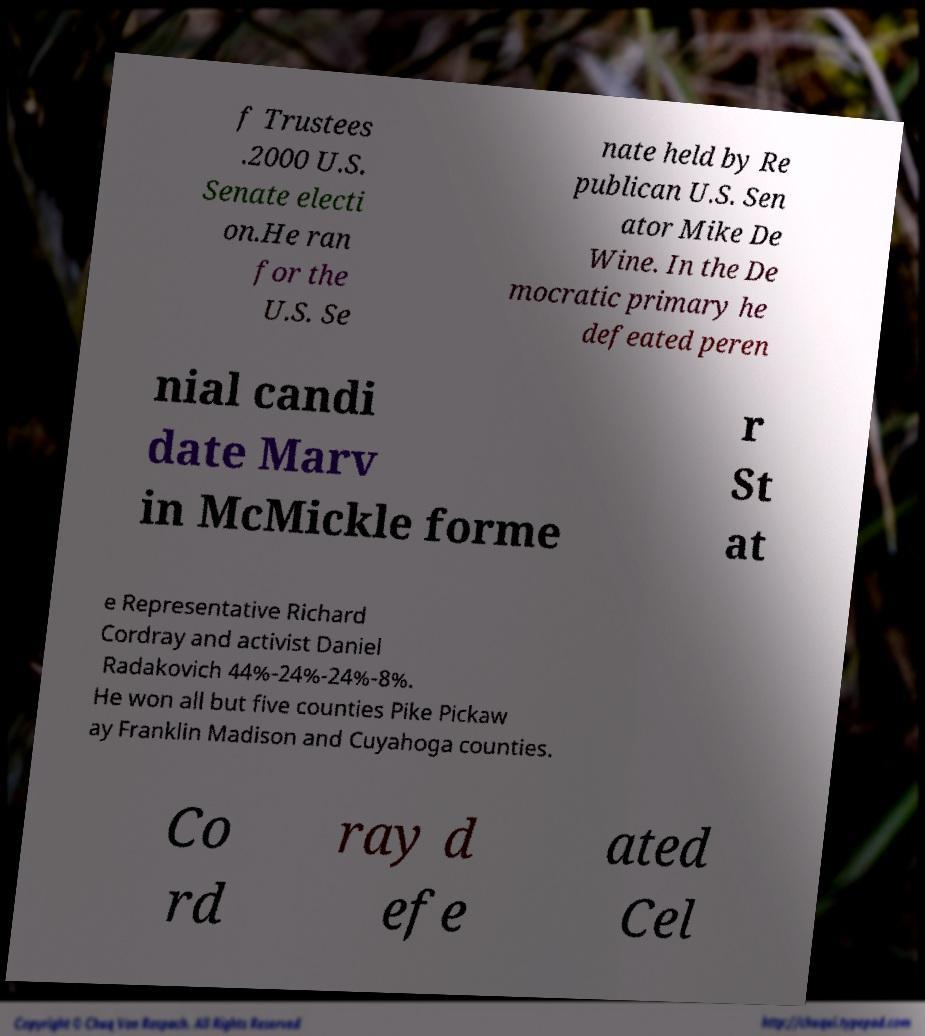Could you extract and type out the text from this image? f Trustees .2000 U.S. Senate electi on.He ran for the U.S. Se nate held by Re publican U.S. Sen ator Mike De Wine. In the De mocratic primary he defeated peren nial candi date Marv in McMickle forme r St at e Representative Richard Cordray and activist Daniel Radakovich 44%-24%-24%-8%. He won all but five counties Pike Pickaw ay Franklin Madison and Cuyahoga counties. Co rd ray d efe ated Cel 